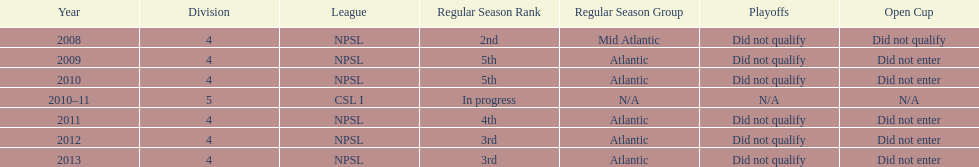Which year was more successful, 2010 or 2013? 2013. 